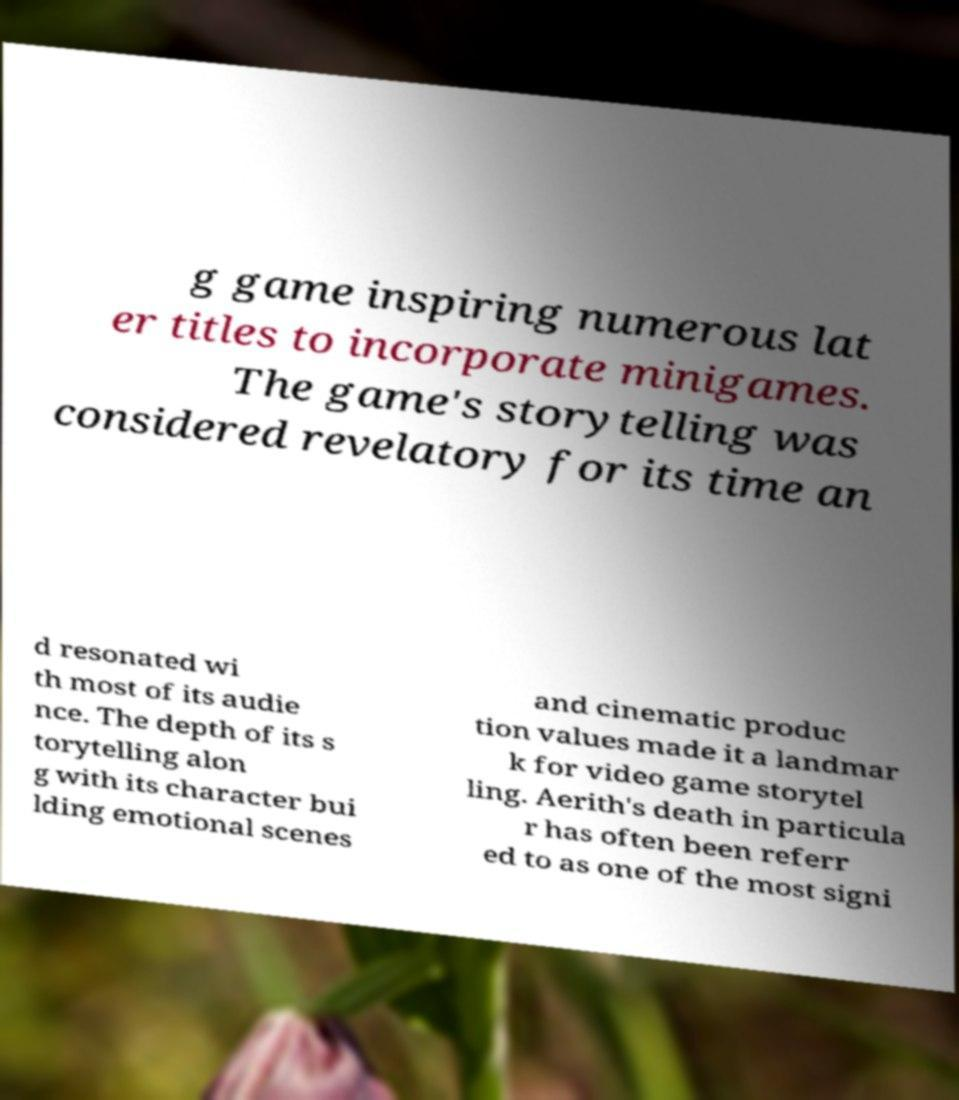For documentation purposes, I need the text within this image transcribed. Could you provide that? g game inspiring numerous lat er titles to incorporate minigames. The game's storytelling was considered revelatory for its time an d resonated wi th most of its audie nce. The depth of its s torytelling alon g with its character bui lding emotional scenes and cinematic produc tion values made it a landmar k for video game storytel ling. Aerith's death in particula r has often been referr ed to as one of the most signi 